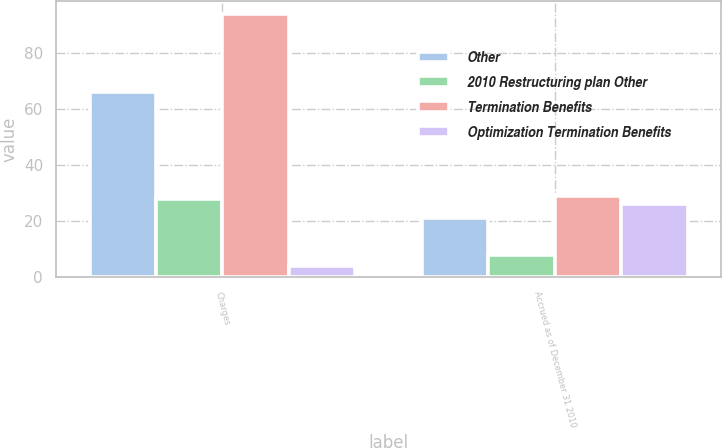Convert chart to OTSL. <chart><loc_0><loc_0><loc_500><loc_500><stacked_bar_chart><ecel><fcel>Charges<fcel>Accrued as of December 31 2010<nl><fcel>Other<fcel>66<fcel>21<nl><fcel>2010 Restructuring plan Other<fcel>28<fcel>8<nl><fcel>Termination Benefits<fcel>94<fcel>29<nl><fcel>Optimization Termination Benefits<fcel>4<fcel>26<nl></chart> 